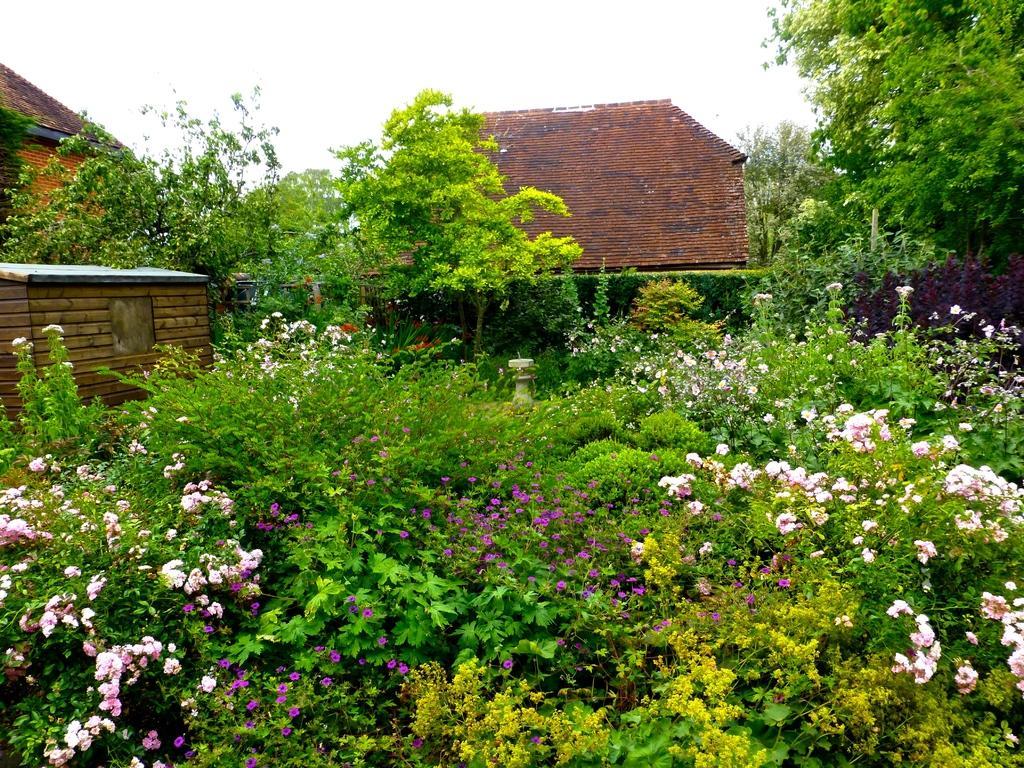Could you give a brief overview of what you see in this image? As we can see in the image there is lot of greenery and there are plants with flowers on it. The flowers are in pink and purple colour and there are lot of trees all around and beside it there are buildings which are of red brick and there is a clear sky on the above. 